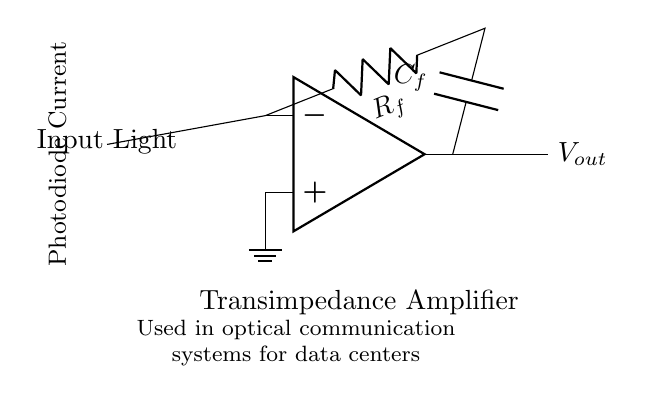What is the input component in this circuit? The input component is a photodiode, represented as PD in the diagram. It is located at the left side of the circuit, and it converts incoming light into an electrical current.
Answer: photodiode What does the feedback resistor do in this transimpedance amplifier? The feedback resistor, labeled as R_f, converts the input current from the photodiode into a voltage output. It allows control over the gain of the amplifier by setting the feedback path.
Answer: converts current to voltage What type of amplifier is shown in the circuit diagram? The circuit diagram represents a transimpedance amplifier, which is specifically designed to convert current from a photodiode into a voltage signal.
Answer: transimpedance amplifier What is the purpose of capacitor C_f in this circuit? Capacitor C_f is used to stabilize the circuit and improve the frequency response by filtering high-frequency noise or ripple from the output signal.
Answer: stabilize and filter What is the output voltage of this circuit indicated as? The output voltage is indicated as V_out, which represents the voltage signal produced by the amplifier based on the input current from the photodiode.
Answer: V_out How does the connection of the photodiode to the op-amp affect the circuit operation? The photodiode is connected to the inverting input of the operational amplifier, meaning that the current generated by the photodiode is what the amplifier responds to, leading to a voltage output based on that current.
Answer: operational amplifier input 